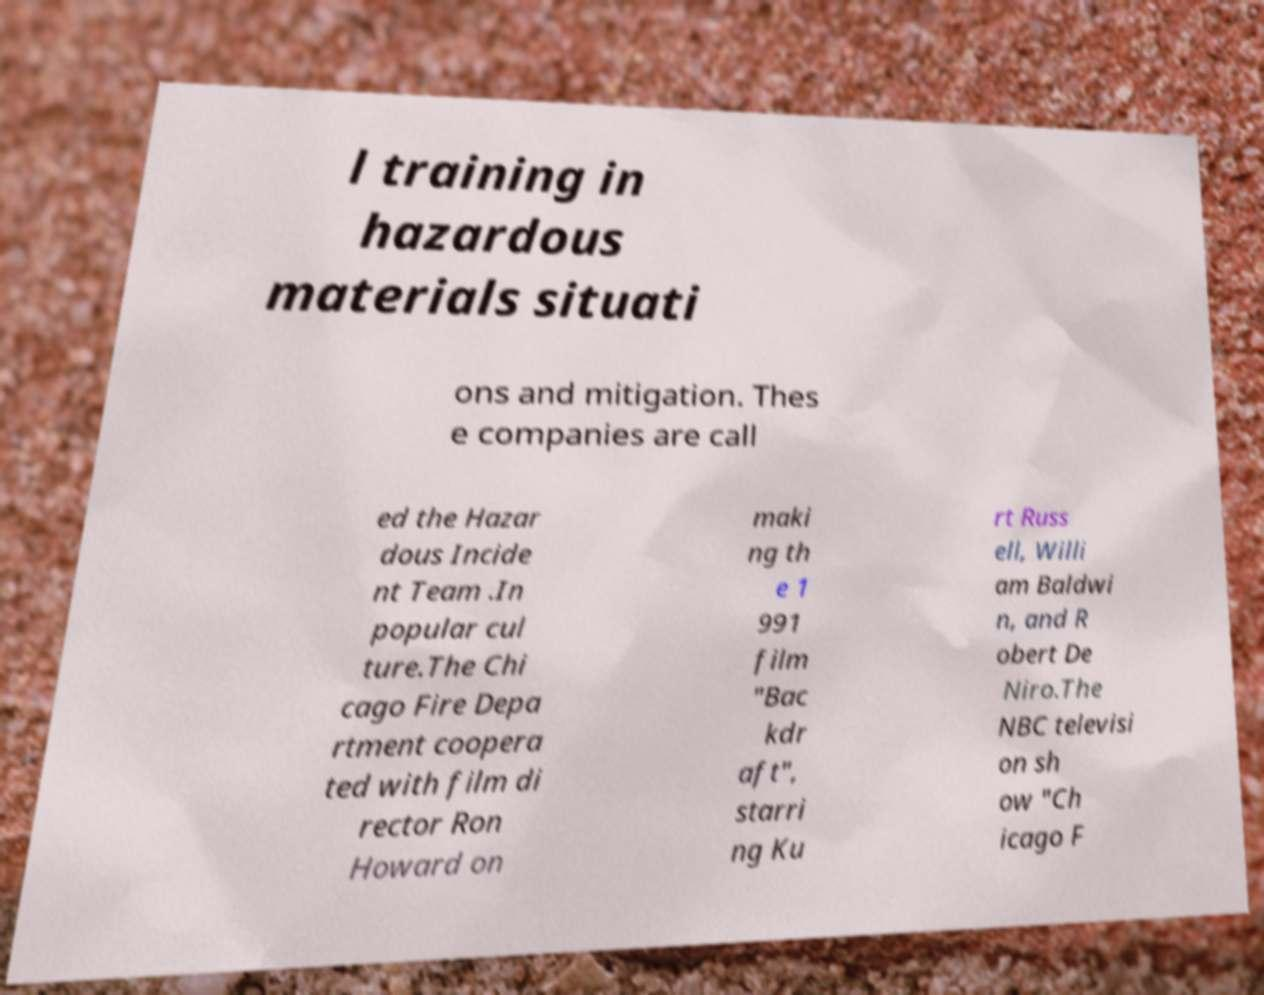Please identify and transcribe the text found in this image. l training in hazardous materials situati ons and mitigation. Thes e companies are call ed the Hazar dous Incide nt Team .In popular cul ture.The Chi cago Fire Depa rtment coopera ted with film di rector Ron Howard on maki ng th e 1 991 film "Bac kdr aft", starri ng Ku rt Russ ell, Willi am Baldwi n, and R obert De Niro.The NBC televisi on sh ow "Ch icago F 